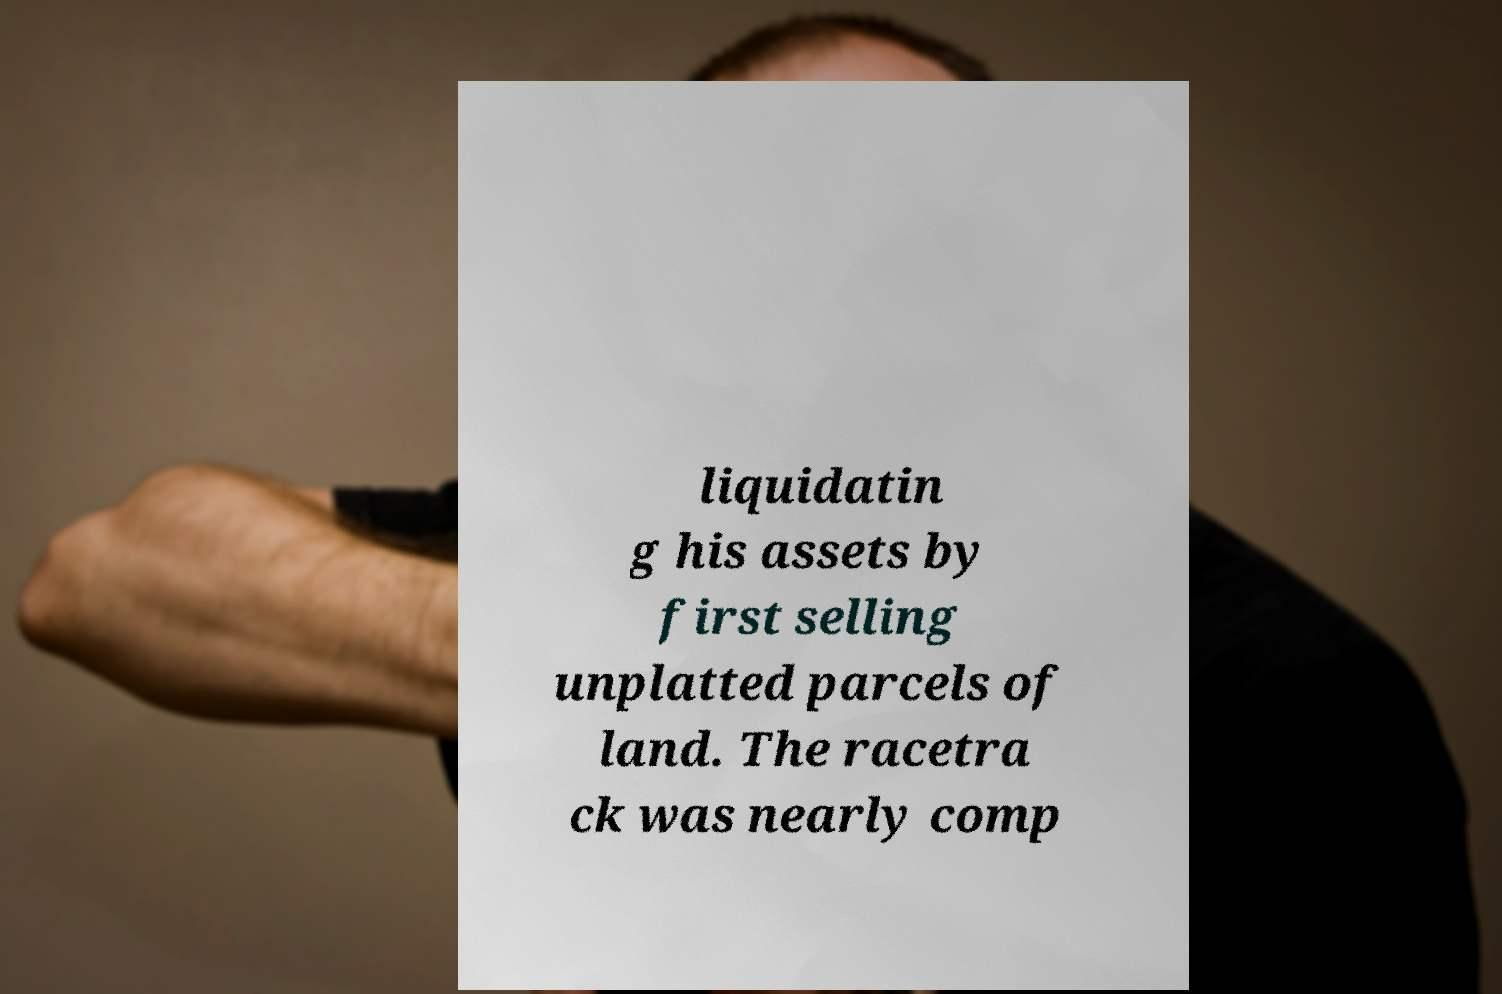I need the written content from this picture converted into text. Can you do that? liquidatin g his assets by first selling unplatted parcels of land. The racetra ck was nearly comp 